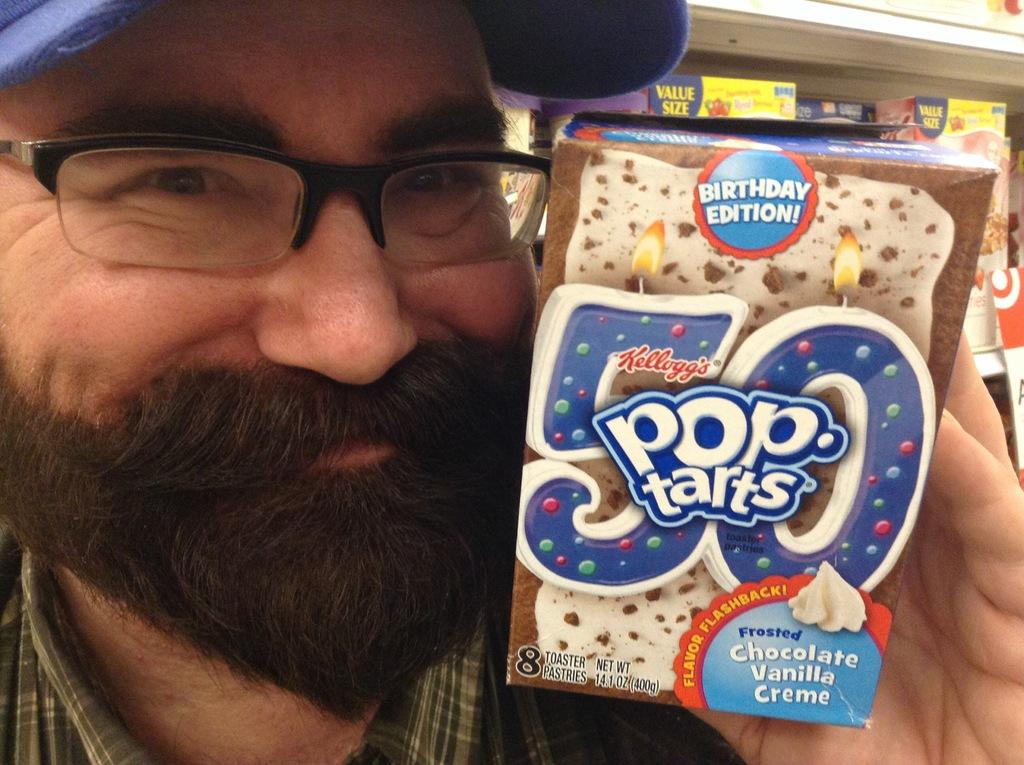What is the main subject of the image? The main subject of the image is a man. Can you describe the man's appearance in the image? The man is wearing spectacles and a cap in the image. What is the man holding in the image? The man is holding a box in the image. What can be seen in the background of the image? There are additional boxes stored in racks in the background of the image. What subject is the man teaching in the image? There is no indication in the image that the man is teaching a subject. What is the man's income based on the image? There is no information about the man's income in the image. 